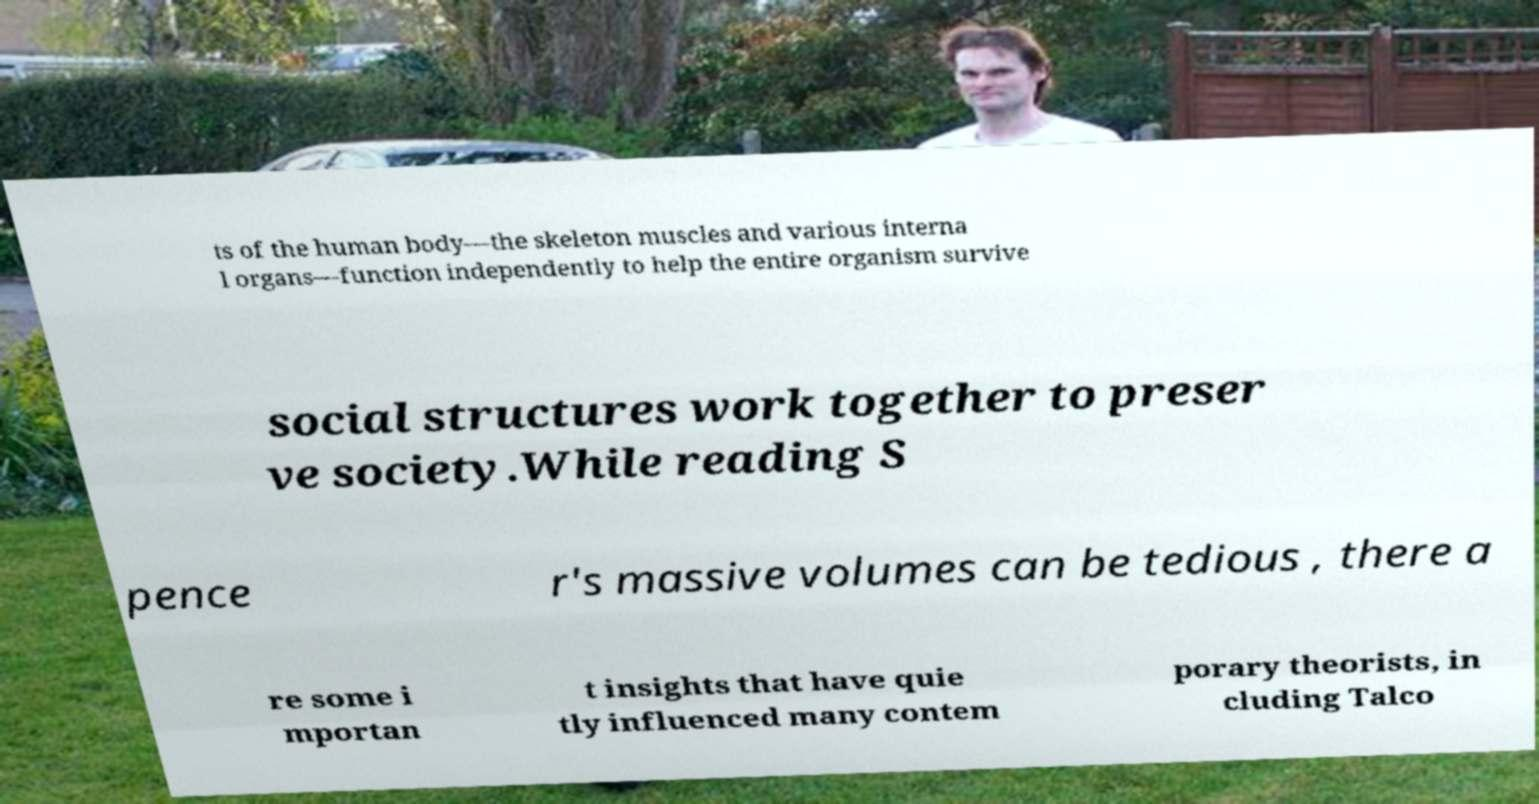What messages or text are displayed in this image? I need them in a readable, typed format. ts of the human body—the skeleton muscles and various interna l organs—function independently to help the entire organism survive social structures work together to preser ve society.While reading S pence r's massive volumes can be tedious , there a re some i mportan t insights that have quie tly influenced many contem porary theorists, in cluding Talco 